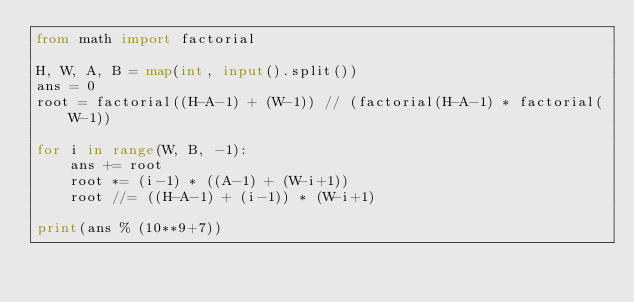<code> <loc_0><loc_0><loc_500><loc_500><_Python_>from math import factorial

H, W, A, B = map(int, input().split())
ans = 0
root = factorial((H-A-1) + (W-1)) // (factorial(H-A-1) * factorial(W-1))

for i in range(W, B, -1):
    ans += root
    root *= (i-1) * ((A-1) + (W-i+1))
    root //= ((H-A-1) + (i-1)) * (W-i+1)

print(ans % (10**9+7))</code> 